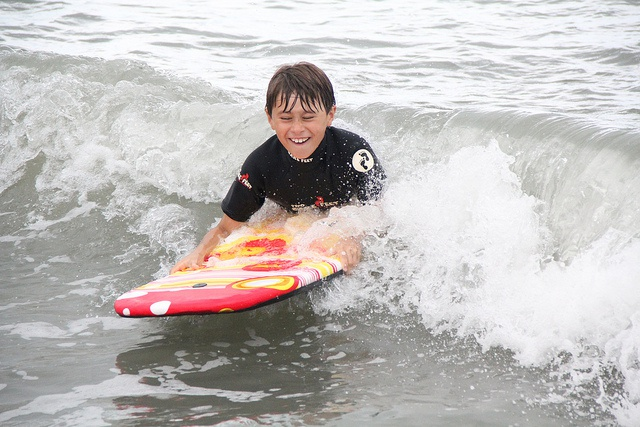Describe the objects in this image and their specific colors. I can see people in gray, black, lightgray, and tan tones and surfboard in gray, white, lightpink, khaki, and salmon tones in this image. 